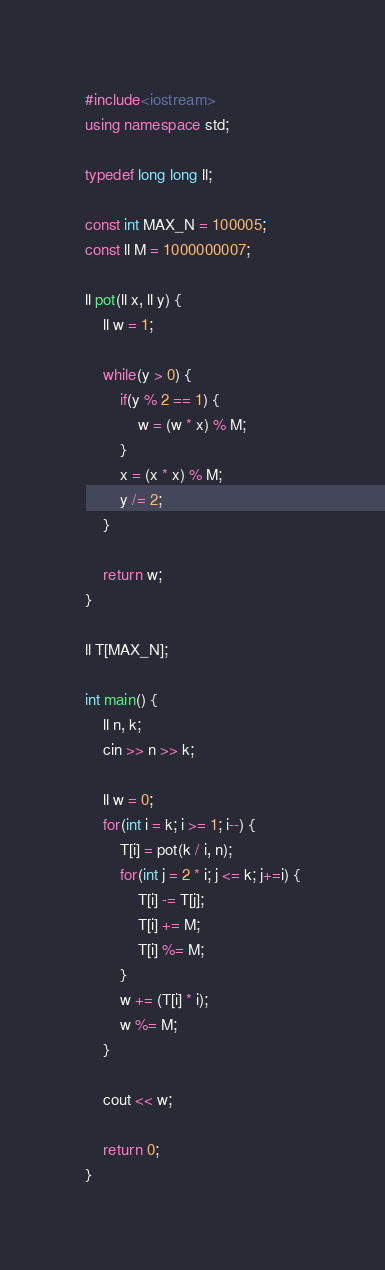<code> <loc_0><loc_0><loc_500><loc_500><_C++_>#include<iostream>
using namespace std;

typedef long long ll;

const int MAX_N = 100005;
const ll M = 1000000007;

ll pot(ll x, ll y) {
    ll w = 1;

    while(y > 0) {
        if(y % 2 == 1) {
            w = (w * x) % M;
        }
        x = (x * x) % M;
        y /= 2;
    }

    return w;
}

ll T[MAX_N];

int main() {
    ll n, k;
    cin >> n >> k;

    ll w = 0;
    for(int i = k; i >= 1; i--) {
        T[i] = pot(k / i, n);
        for(int j = 2 * i; j <= k; j+=i) {
            T[i] -= T[j];
            T[i] += M;
            T[i] %= M;
        }
        w += (T[i] * i);
        w %= M;
    }

    cout << w;

    return 0;
}</code> 